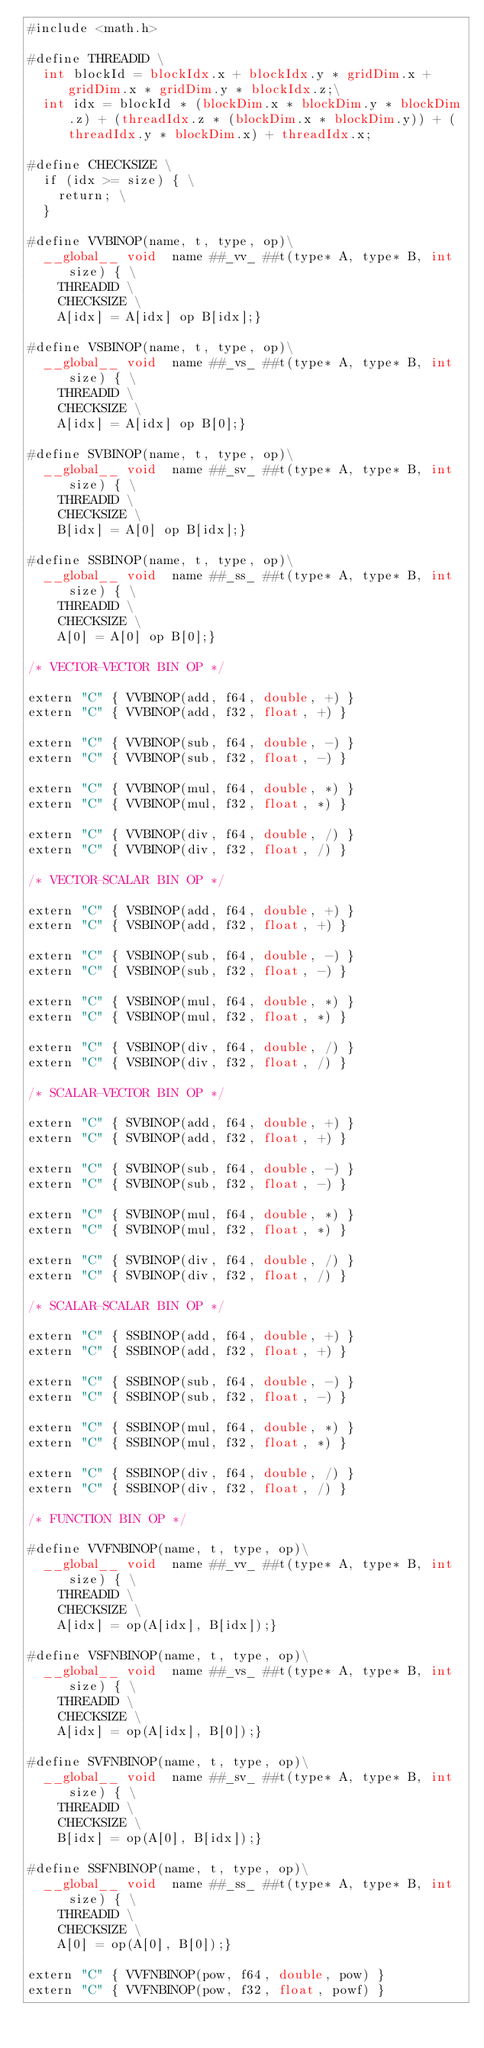Convert code to text. <code><loc_0><loc_0><loc_500><loc_500><_Cuda_>#include <math.h>

#define THREADID \
	int blockId = blockIdx.x + blockIdx.y * gridDim.x + gridDim.x * gridDim.y * blockIdx.z;\
	int idx = blockId * (blockDim.x * blockDim.y * blockDim.z) + (threadIdx.z * (blockDim.x * blockDim.y)) + (threadIdx.y * blockDim.x) + threadIdx.x;

#define CHECKSIZE \
	if (idx >= size) { \
		return; \
	}

#define VVBINOP(name, t, type, op)\
	__global__ void  name ##_vv_ ##t(type* A, type* B, int size) { \
		THREADID \
		CHECKSIZE \
		A[idx] = A[idx] op B[idx];}

#define VSBINOP(name, t, type, op)\
	__global__ void  name ##_vs_ ##t(type* A, type* B, int size) { \
		THREADID \
		CHECKSIZE \
		A[idx] = A[idx] op B[0];}

#define SVBINOP(name, t, type, op)\
	__global__ void  name ##_sv_ ##t(type* A, type* B, int size) { \
		THREADID \
		CHECKSIZE \
		B[idx] = A[0] op B[idx];}

#define SSBINOP(name, t, type, op)\
	__global__ void  name ##_ss_ ##t(type* A, type* B, int size) { \
		THREADID \
		CHECKSIZE \
		A[0] = A[0] op B[0];}

/* VECTOR-VECTOR BIN OP */

extern "C" { VVBINOP(add, f64, double, +) }
extern "C" { VVBINOP(add, f32, float, +) }

extern "C" { VVBINOP(sub, f64, double, -) }
extern "C" { VVBINOP(sub, f32, float, -) }

extern "C" { VVBINOP(mul, f64, double, *) }
extern "C" { VVBINOP(mul, f32, float, *) }

extern "C" { VVBINOP(div, f64, double, /) }
extern "C" { VVBINOP(div, f32, float, /) }

/* VECTOR-SCALAR BIN OP */

extern "C" { VSBINOP(add, f64, double, +) }
extern "C" { VSBINOP(add, f32, float, +) }

extern "C" { VSBINOP(sub, f64, double, -) }
extern "C" { VSBINOP(sub, f32, float, -) }

extern "C" { VSBINOP(mul, f64, double, *) }
extern "C" { VSBINOP(mul, f32, float, *) }

extern "C" { VSBINOP(div, f64, double, /) }
extern "C" { VSBINOP(div, f32, float, /) }

/* SCALAR-VECTOR BIN OP */

extern "C" { SVBINOP(add, f64, double, +) }
extern "C" { SVBINOP(add, f32, float, +) }

extern "C" { SVBINOP(sub, f64, double, -) }
extern "C" { SVBINOP(sub, f32, float, -) }

extern "C" { SVBINOP(mul, f64, double, *) }
extern "C" { SVBINOP(mul, f32, float, *) }

extern "C" { SVBINOP(div, f64, double, /) }
extern "C" { SVBINOP(div, f32, float, /) }

/* SCALAR-SCALAR BIN OP */	

extern "C" { SSBINOP(add, f64, double, +) }
extern "C" { SSBINOP(add, f32, float, +) }

extern "C" { SSBINOP(sub, f64, double, -) }
extern "C" { SSBINOP(sub, f32, float, -) }

extern "C" { SSBINOP(mul, f64, double, *) }
extern "C" { SSBINOP(mul, f32, float, *) }

extern "C" { SSBINOP(div, f64, double, /) }
extern "C" { SSBINOP(div, f32, float, /) }

/* FUNCTION BIN OP */

#define VVFNBINOP(name, t, type, op)\
	__global__ void  name ##_vv_ ##t(type* A, type* B, int size) { \
		THREADID \
		CHECKSIZE \
		A[idx] = op(A[idx], B[idx]);}

#define VSFNBINOP(name, t, type, op)\
	__global__ void  name ##_vs_ ##t(type* A, type* B, int size) { \
		THREADID \
		CHECKSIZE \
		A[idx] = op(A[idx], B[0]);}

#define SVFNBINOP(name, t, type, op)\
	__global__ void  name ##_sv_ ##t(type* A, type* B, int size) { \
		THREADID \
		CHECKSIZE \
		B[idx] = op(A[0], B[idx]);}

#define SSFNBINOP(name, t, type, op)\
	__global__ void  name ##_ss_ ##t(type* A, type* B, int size) { \
		THREADID \
		CHECKSIZE \
		A[0] = op(A[0], B[0]);}

extern "C" { VVFNBINOP(pow, f64, double, pow) }
extern "C" { VVFNBINOP(pow, f32, float, powf) }</code> 